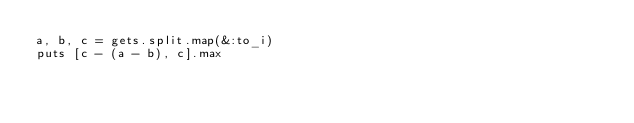Convert code to text. <code><loc_0><loc_0><loc_500><loc_500><_Ruby_>a, b, c = gets.split.map(&:to_i)
puts [c - (a - b), c].max</code> 